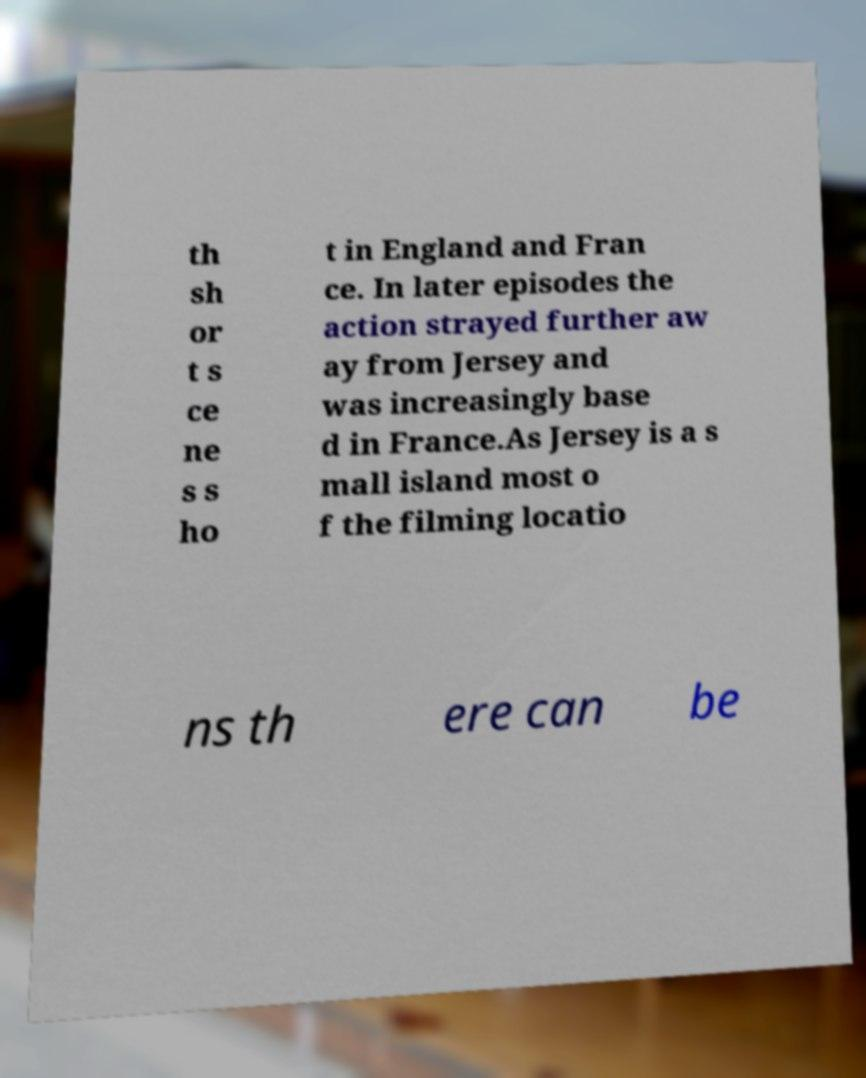What messages or text are displayed in this image? I need them in a readable, typed format. th sh or t s ce ne s s ho t in England and Fran ce. In later episodes the action strayed further aw ay from Jersey and was increasingly base d in France.As Jersey is a s mall island most o f the filming locatio ns th ere can be 